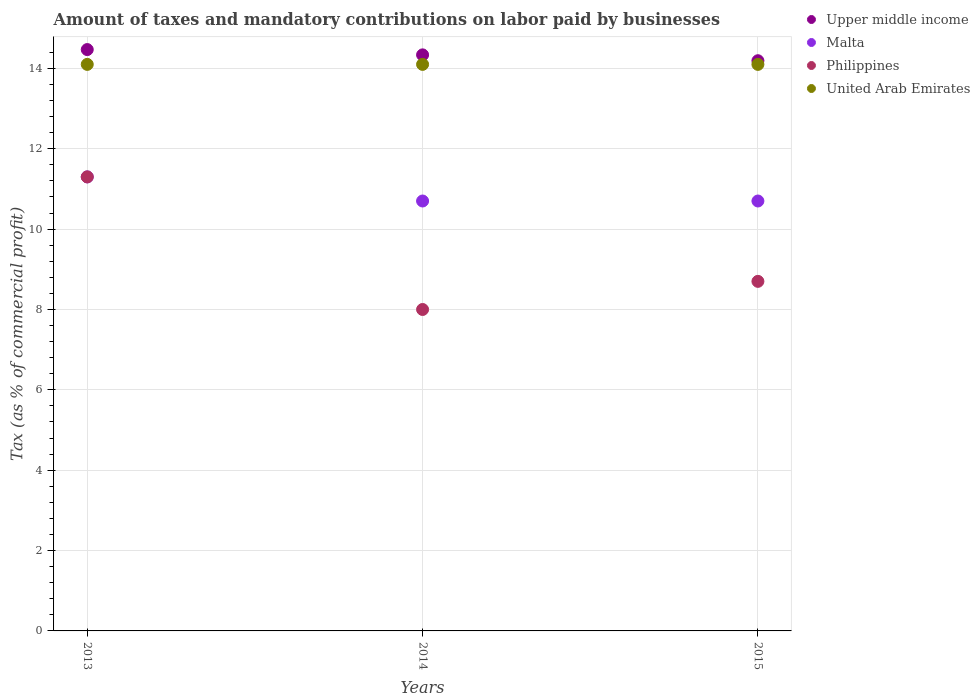How many different coloured dotlines are there?
Provide a succinct answer. 4. Is the number of dotlines equal to the number of legend labels?
Your answer should be very brief. Yes. What is the percentage of taxes paid by businesses in Malta in 2014?
Your response must be concise. 10.7. Across all years, what is the minimum percentage of taxes paid by businesses in United Arab Emirates?
Keep it short and to the point. 14.1. In which year was the percentage of taxes paid by businesses in Upper middle income maximum?
Ensure brevity in your answer.  2013. In which year was the percentage of taxes paid by businesses in Upper middle income minimum?
Provide a succinct answer. 2015. What is the total percentage of taxes paid by businesses in United Arab Emirates in the graph?
Provide a succinct answer. 42.3. What is the difference between the percentage of taxes paid by businesses in Upper middle income in 2014 and that in 2015?
Provide a short and direct response. 0.15. What is the difference between the percentage of taxes paid by businesses in United Arab Emirates in 2015 and the percentage of taxes paid by businesses in Upper middle income in 2013?
Provide a succinct answer. -0.37. What is the average percentage of taxes paid by businesses in Philippines per year?
Keep it short and to the point. 9.33. In the year 2014, what is the difference between the percentage of taxes paid by businesses in Malta and percentage of taxes paid by businesses in Philippines?
Your answer should be very brief. 2.7. What is the ratio of the percentage of taxes paid by businesses in United Arab Emirates in 2014 to that in 2015?
Make the answer very short. 1. Is the percentage of taxes paid by businesses in Malta in 2013 less than that in 2015?
Give a very brief answer. No. What is the difference between the highest and the second highest percentage of taxes paid by businesses in United Arab Emirates?
Keep it short and to the point. 0. What is the difference between the highest and the lowest percentage of taxes paid by businesses in Malta?
Offer a terse response. 0.6. Is the sum of the percentage of taxes paid by businesses in Upper middle income in 2013 and 2014 greater than the maximum percentage of taxes paid by businesses in Malta across all years?
Provide a short and direct response. Yes. Is it the case that in every year, the sum of the percentage of taxes paid by businesses in United Arab Emirates and percentage of taxes paid by businesses in Upper middle income  is greater than the percentage of taxes paid by businesses in Malta?
Offer a terse response. Yes. Does the percentage of taxes paid by businesses in United Arab Emirates monotonically increase over the years?
Your response must be concise. No. Is the percentage of taxes paid by businesses in United Arab Emirates strictly greater than the percentage of taxes paid by businesses in Malta over the years?
Offer a very short reply. Yes. How many dotlines are there?
Your answer should be compact. 4. Does the graph contain any zero values?
Your response must be concise. No. Where does the legend appear in the graph?
Your response must be concise. Top right. How many legend labels are there?
Offer a very short reply. 4. How are the legend labels stacked?
Provide a short and direct response. Vertical. What is the title of the graph?
Your response must be concise. Amount of taxes and mandatory contributions on labor paid by businesses. Does "Channel Islands" appear as one of the legend labels in the graph?
Your answer should be very brief. No. What is the label or title of the Y-axis?
Your response must be concise. Tax (as % of commercial profit). What is the Tax (as % of commercial profit) of Upper middle income in 2013?
Your response must be concise. 14.47. What is the Tax (as % of commercial profit) of United Arab Emirates in 2013?
Make the answer very short. 14.1. What is the Tax (as % of commercial profit) in Upper middle income in 2014?
Provide a short and direct response. 14.34. What is the Tax (as % of commercial profit) in Philippines in 2014?
Give a very brief answer. 8. What is the Tax (as % of commercial profit) of United Arab Emirates in 2014?
Ensure brevity in your answer.  14.1. What is the Tax (as % of commercial profit) in Upper middle income in 2015?
Provide a short and direct response. 14.19. Across all years, what is the maximum Tax (as % of commercial profit) of Upper middle income?
Provide a short and direct response. 14.47. Across all years, what is the maximum Tax (as % of commercial profit) in Philippines?
Your answer should be very brief. 11.3. Across all years, what is the maximum Tax (as % of commercial profit) in United Arab Emirates?
Your answer should be compact. 14.1. Across all years, what is the minimum Tax (as % of commercial profit) in Upper middle income?
Give a very brief answer. 14.19. Across all years, what is the minimum Tax (as % of commercial profit) in Philippines?
Your answer should be very brief. 8. What is the total Tax (as % of commercial profit) of Upper middle income in the graph?
Provide a short and direct response. 43. What is the total Tax (as % of commercial profit) of Malta in the graph?
Your response must be concise. 32.7. What is the total Tax (as % of commercial profit) in United Arab Emirates in the graph?
Offer a very short reply. 42.3. What is the difference between the Tax (as % of commercial profit) in Upper middle income in 2013 and that in 2014?
Offer a very short reply. 0.13. What is the difference between the Tax (as % of commercial profit) of Philippines in 2013 and that in 2014?
Ensure brevity in your answer.  3.3. What is the difference between the Tax (as % of commercial profit) of United Arab Emirates in 2013 and that in 2014?
Give a very brief answer. 0. What is the difference between the Tax (as % of commercial profit) of Upper middle income in 2013 and that in 2015?
Offer a very short reply. 0.28. What is the difference between the Tax (as % of commercial profit) in Malta in 2013 and that in 2015?
Keep it short and to the point. 0.6. What is the difference between the Tax (as % of commercial profit) of Philippines in 2013 and that in 2015?
Keep it short and to the point. 2.6. What is the difference between the Tax (as % of commercial profit) in United Arab Emirates in 2013 and that in 2015?
Keep it short and to the point. 0. What is the difference between the Tax (as % of commercial profit) of Upper middle income in 2014 and that in 2015?
Provide a short and direct response. 0.15. What is the difference between the Tax (as % of commercial profit) in Malta in 2014 and that in 2015?
Provide a succinct answer. 0. What is the difference between the Tax (as % of commercial profit) in Philippines in 2014 and that in 2015?
Your response must be concise. -0.7. What is the difference between the Tax (as % of commercial profit) of Upper middle income in 2013 and the Tax (as % of commercial profit) of Malta in 2014?
Keep it short and to the point. 3.77. What is the difference between the Tax (as % of commercial profit) in Upper middle income in 2013 and the Tax (as % of commercial profit) in Philippines in 2014?
Provide a short and direct response. 6.47. What is the difference between the Tax (as % of commercial profit) in Upper middle income in 2013 and the Tax (as % of commercial profit) in United Arab Emirates in 2014?
Provide a short and direct response. 0.37. What is the difference between the Tax (as % of commercial profit) in Philippines in 2013 and the Tax (as % of commercial profit) in United Arab Emirates in 2014?
Provide a succinct answer. -2.8. What is the difference between the Tax (as % of commercial profit) of Upper middle income in 2013 and the Tax (as % of commercial profit) of Malta in 2015?
Ensure brevity in your answer.  3.77. What is the difference between the Tax (as % of commercial profit) of Upper middle income in 2013 and the Tax (as % of commercial profit) of Philippines in 2015?
Provide a succinct answer. 5.77. What is the difference between the Tax (as % of commercial profit) in Upper middle income in 2013 and the Tax (as % of commercial profit) in United Arab Emirates in 2015?
Offer a very short reply. 0.37. What is the difference between the Tax (as % of commercial profit) of Upper middle income in 2014 and the Tax (as % of commercial profit) of Malta in 2015?
Keep it short and to the point. 3.64. What is the difference between the Tax (as % of commercial profit) in Upper middle income in 2014 and the Tax (as % of commercial profit) in Philippines in 2015?
Your answer should be compact. 5.64. What is the difference between the Tax (as % of commercial profit) of Upper middle income in 2014 and the Tax (as % of commercial profit) of United Arab Emirates in 2015?
Provide a succinct answer. 0.24. What is the difference between the Tax (as % of commercial profit) in Malta in 2014 and the Tax (as % of commercial profit) in Philippines in 2015?
Keep it short and to the point. 2. What is the average Tax (as % of commercial profit) in Upper middle income per year?
Your response must be concise. 14.33. What is the average Tax (as % of commercial profit) of Philippines per year?
Provide a succinct answer. 9.33. What is the average Tax (as % of commercial profit) in United Arab Emirates per year?
Ensure brevity in your answer.  14.1. In the year 2013, what is the difference between the Tax (as % of commercial profit) of Upper middle income and Tax (as % of commercial profit) of Malta?
Your answer should be compact. 3.17. In the year 2013, what is the difference between the Tax (as % of commercial profit) in Upper middle income and Tax (as % of commercial profit) in Philippines?
Make the answer very short. 3.17. In the year 2013, what is the difference between the Tax (as % of commercial profit) of Upper middle income and Tax (as % of commercial profit) of United Arab Emirates?
Make the answer very short. 0.37. In the year 2013, what is the difference between the Tax (as % of commercial profit) in Malta and Tax (as % of commercial profit) in United Arab Emirates?
Keep it short and to the point. -2.8. In the year 2014, what is the difference between the Tax (as % of commercial profit) in Upper middle income and Tax (as % of commercial profit) in Malta?
Keep it short and to the point. 3.64. In the year 2014, what is the difference between the Tax (as % of commercial profit) of Upper middle income and Tax (as % of commercial profit) of Philippines?
Give a very brief answer. 6.34. In the year 2014, what is the difference between the Tax (as % of commercial profit) in Upper middle income and Tax (as % of commercial profit) in United Arab Emirates?
Provide a succinct answer. 0.24. In the year 2014, what is the difference between the Tax (as % of commercial profit) of Philippines and Tax (as % of commercial profit) of United Arab Emirates?
Provide a short and direct response. -6.1. In the year 2015, what is the difference between the Tax (as % of commercial profit) in Upper middle income and Tax (as % of commercial profit) in Malta?
Provide a succinct answer. 3.49. In the year 2015, what is the difference between the Tax (as % of commercial profit) of Upper middle income and Tax (as % of commercial profit) of Philippines?
Provide a succinct answer. 5.49. In the year 2015, what is the difference between the Tax (as % of commercial profit) of Upper middle income and Tax (as % of commercial profit) of United Arab Emirates?
Provide a short and direct response. 0.09. In the year 2015, what is the difference between the Tax (as % of commercial profit) of Malta and Tax (as % of commercial profit) of Philippines?
Your response must be concise. 2. In the year 2015, what is the difference between the Tax (as % of commercial profit) of Philippines and Tax (as % of commercial profit) of United Arab Emirates?
Your response must be concise. -5.4. What is the ratio of the Tax (as % of commercial profit) in Upper middle income in 2013 to that in 2014?
Offer a very short reply. 1.01. What is the ratio of the Tax (as % of commercial profit) in Malta in 2013 to that in 2014?
Provide a short and direct response. 1.06. What is the ratio of the Tax (as % of commercial profit) in Philippines in 2013 to that in 2014?
Provide a short and direct response. 1.41. What is the ratio of the Tax (as % of commercial profit) of Upper middle income in 2013 to that in 2015?
Keep it short and to the point. 1.02. What is the ratio of the Tax (as % of commercial profit) in Malta in 2013 to that in 2015?
Provide a short and direct response. 1.06. What is the ratio of the Tax (as % of commercial profit) of Philippines in 2013 to that in 2015?
Provide a short and direct response. 1.3. What is the ratio of the Tax (as % of commercial profit) in Upper middle income in 2014 to that in 2015?
Your response must be concise. 1.01. What is the ratio of the Tax (as % of commercial profit) in Philippines in 2014 to that in 2015?
Give a very brief answer. 0.92. What is the ratio of the Tax (as % of commercial profit) of United Arab Emirates in 2014 to that in 2015?
Your answer should be compact. 1. What is the difference between the highest and the second highest Tax (as % of commercial profit) in Upper middle income?
Your answer should be very brief. 0.13. What is the difference between the highest and the second highest Tax (as % of commercial profit) of Philippines?
Your response must be concise. 2.6. What is the difference between the highest and the lowest Tax (as % of commercial profit) in Upper middle income?
Provide a short and direct response. 0.28. What is the difference between the highest and the lowest Tax (as % of commercial profit) in United Arab Emirates?
Give a very brief answer. 0. 